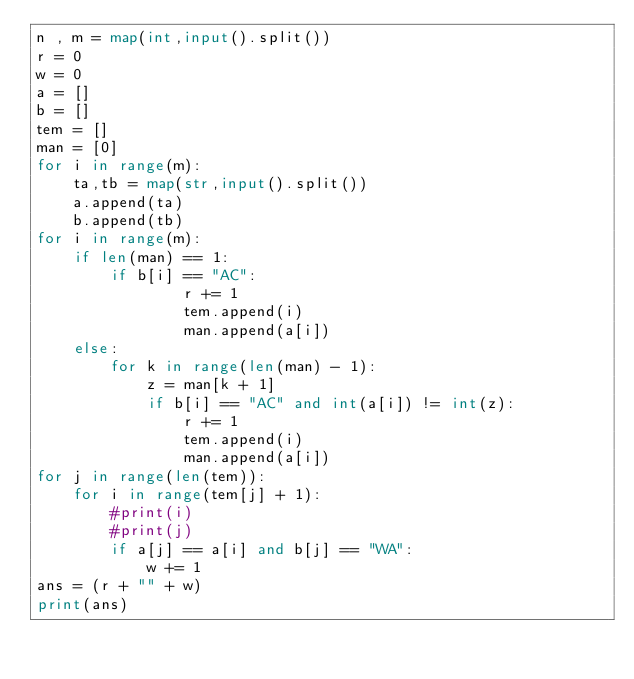Convert code to text. <code><loc_0><loc_0><loc_500><loc_500><_Python_>n , m = map(int,input().split())
r = 0
w = 0
a = []
b = []
tem = []
man = [0]
for i in range(m):
    ta,tb = map(str,input().split())
    a.append(ta)
    b.append(tb)
for i in range(m):
    if len(man) == 1:
        if b[i] == "AC":
                r += 1
                tem.append(i)
                man.append(a[i])
    else:
        for k in range(len(man) - 1):
            z = man[k + 1]
            if b[i] == "AC" and int(a[i]) != int(z):
                r += 1
                tem.append(i)
                man.append(a[i])
for j in range(len(tem)):
    for i in range(tem[j] + 1):
        #print(i)
        #print(j)
        if a[j] == a[i] and b[j] == "WA":
            w += 1
ans = (r + "" + w)
print(ans)</code> 